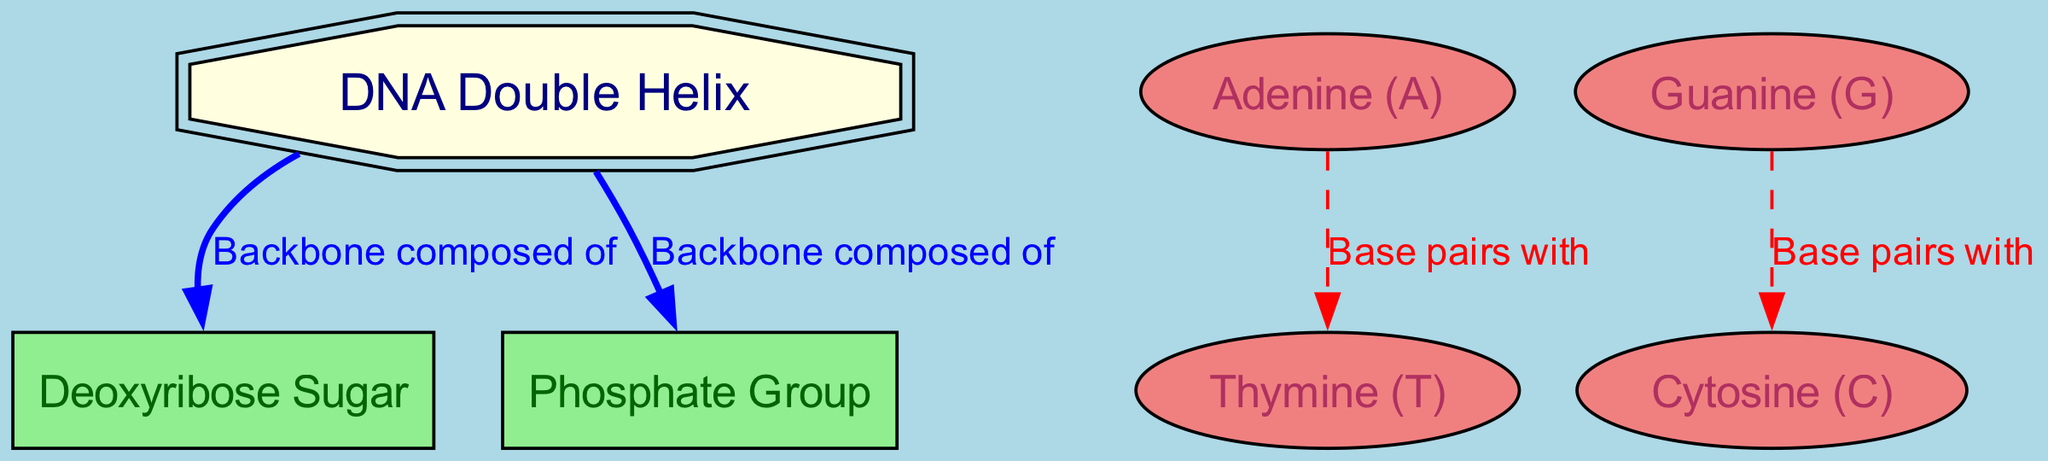What is the main structure depicted in the diagram? The diagram portrays a DNA double helix, which is the primary structure of DNA. This can be identified as the central element labeled "DNA Double Helix."
Answer: DNA Double Helix How many types of nucleotides are shown in the diagram? The diagram displays four types of nucleotides: Adenine, Thymine, Guanine, and Cytosine, each representing the specific bases in DNA.
Answer: Four Which sugar is part of the backbone of the DNA structure? The backbone of the DNA structure includes Deoxyribose Sugar, which is specified in the diagram as one component of the backbone.
Answer: Deoxyribose Sugar What do Adenine and Thymine do in the DNA structure? Adenine pairs with Thymine in base pairing, which is clearly indicated by a connecting line in the diagram labeled "Base pairs with."
Answer: Base pairs with What is the relationship between Guanine and Cytosine? In the diagram, Guanine is shown to base pair with Cytosine through a dashed line labeled "Base pairs with," indicating their complementary relationship.
Answer: Base pairs with What are the components that make up the DNA backbone? The DNA backbone consists of Deoxyribose Sugar and a Phosphate Group, which are both explicitly mentioned in the diagram as part of the backbone composition.
Answer: Deoxyribose Sugar and Phosphate Group How is the DNA visually represented in the diagram? The diagram uses a double octagon shape filled with yellow to visually represent the DNA Double Helix, highlighting its significance.
Answer: Double octagon Which edges in the diagram are dashed? The edges connecting the base pairs, specifically Adenine to Thymine and Guanine to Cytosine, are dashed; this distinction indicates a different type of relationship compared to the backbone components.
Answer: Edges connecting the base pairs What color is the phosphate group represented as in the diagram? The Phosphate Group is colored light green in the diagram, differentiating it from other components such as the DNA and nucleotides.
Answer: Light green 